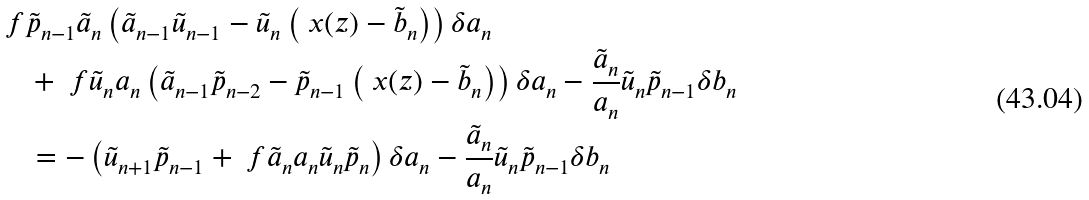<formula> <loc_0><loc_0><loc_500><loc_500>& \ f { \tilde { p } _ { n - 1 } } { \tilde { a } _ { n } } \left ( \tilde { a } _ { n - 1 } \tilde { u } _ { n - 1 } - \tilde { u } _ { n } \left ( \ x ( z ) - \tilde { b } _ { n } \right ) \right ) \delta a _ { n } \\ & \quad + \ f { \tilde { u } _ { n } } { a _ { n } } \left ( \tilde { a } _ { n - 1 } \tilde { p } _ { n - 2 } - \tilde { p } _ { n - 1 } \left ( \ x ( z ) - \tilde { b } _ { n } \right ) \right ) \delta a _ { n } - \frac { \tilde { a } _ { n } } { a _ { n } } \tilde { u } _ { n } \tilde { p } _ { n - 1 } \delta b _ { n } \\ & \quad = - \left ( \tilde { u } _ { n + 1 } \tilde { p } _ { n - 1 } + \ f { \tilde { a } _ { n } } { a _ { n } } \tilde { u } _ { n } \tilde { p } _ { n } \right ) \delta a _ { n } - \frac { \tilde { a } _ { n } } { a _ { n } } \tilde { u } _ { n } \tilde { p } _ { n - 1 } \delta b _ { n }</formula> 